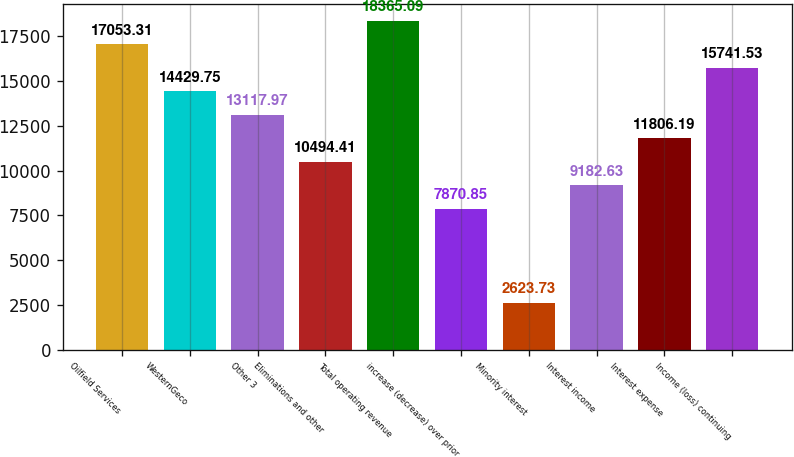<chart> <loc_0><loc_0><loc_500><loc_500><bar_chart><fcel>Oilfield Services<fcel>WesternGeco<fcel>Other 3<fcel>Eliminations and other<fcel>Total operating revenue<fcel>increase (decrease) over prior<fcel>Minority interest<fcel>Interest income<fcel>Interest expense<fcel>Income (loss) continuing<nl><fcel>17053.3<fcel>14429.8<fcel>13118<fcel>10494.4<fcel>18365.1<fcel>7870.85<fcel>2623.73<fcel>9182.63<fcel>11806.2<fcel>15741.5<nl></chart> 